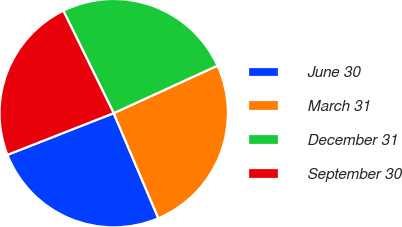Convert chart. <chart><loc_0><loc_0><loc_500><loc_500><pie_chart><fcel>June 30<fcel>March 31<fcel>December 31<fcel>September 30<nl><fcel>25.44%<fcel>25.44%<fcel>25.44%<fcel>23.67%<nl></chart> 